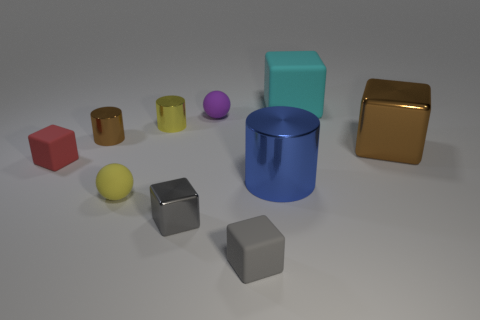Are there fewer tiny brown metal cylinders that are to the right of the small yellow sphere than small blue rubber spheres? From observing the image, it appears that the tiny brown metal cylinders to the right of the small yellow sphere are indeed fewer in number than the small blue rubber spheres present. 